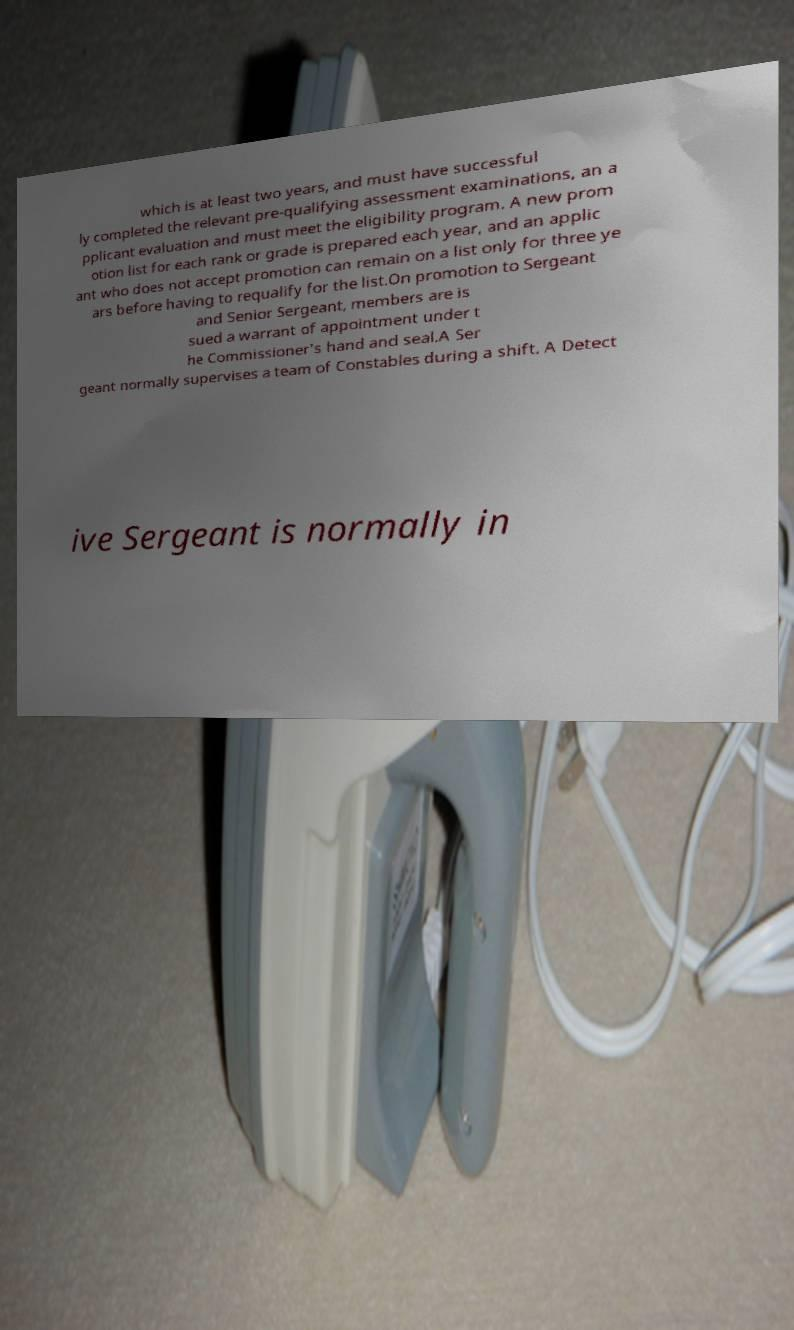Please identify and transcribe the text found in this image. which is at least two years, and must have successful ly completed the relevant pre-qualifying assessment examinations, an a pplicant evaluation and must meet the eligibility program. A new prom otion list for each rank or grade is prepared each year, and an applic ant who does not accept promotion can remain on a list only for three ye ars before having to requalify for the list.On promotion to Sergeant and Senior Sergeant, members are is sued a warrant of appointment under t he Commissioner's hand and seal.A Ser geant normally supervises a team of Constables during a shift. A Detect ive Sergeant is normally in 